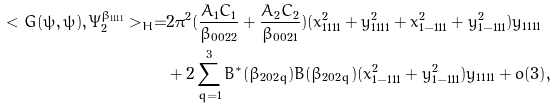Convert formula to latex. <formula><loc_0><loc_0><loc_500><loc_500>< G ( \psi , \psi ) , \Psi ^ { \beta _ { 1 1 1 1 } } _ { 2 } > _ { H } = & 2 \pi ^ { 2 } ( \frac { A _ { 1 } C _ { 1 } } { \beta _ { 0 0 2 2 } } + \frac { A _ { 2 } C _ { 2 } } { \beta _ { 0 0 2 1 } } ) ( x _ { 1 1 1 1 } ^ { 2 } + y _ { 1 1 1 1 } ^ { 2 } + x _ { 1 - 1 1 1 } ^ { 2 } + y _ { 1 - 1 1 1 } ^ { 2 } ) y _ { 1 1 1 1 } \\ & + 2 \sum _ { q = 1 } ^ { 3 } B ^ { * } ( \beta _ { 2 0 2 q } ) B ( \beta _ { 2 0 2 q } ) ( x _ { 1 - 1 1 1 } ^ { 2 } + y _ { 1 - 1 1 1 } ^ { 2 } ) y _ { 1 1 1 1 } + o ( 3 ) ,</formula> 